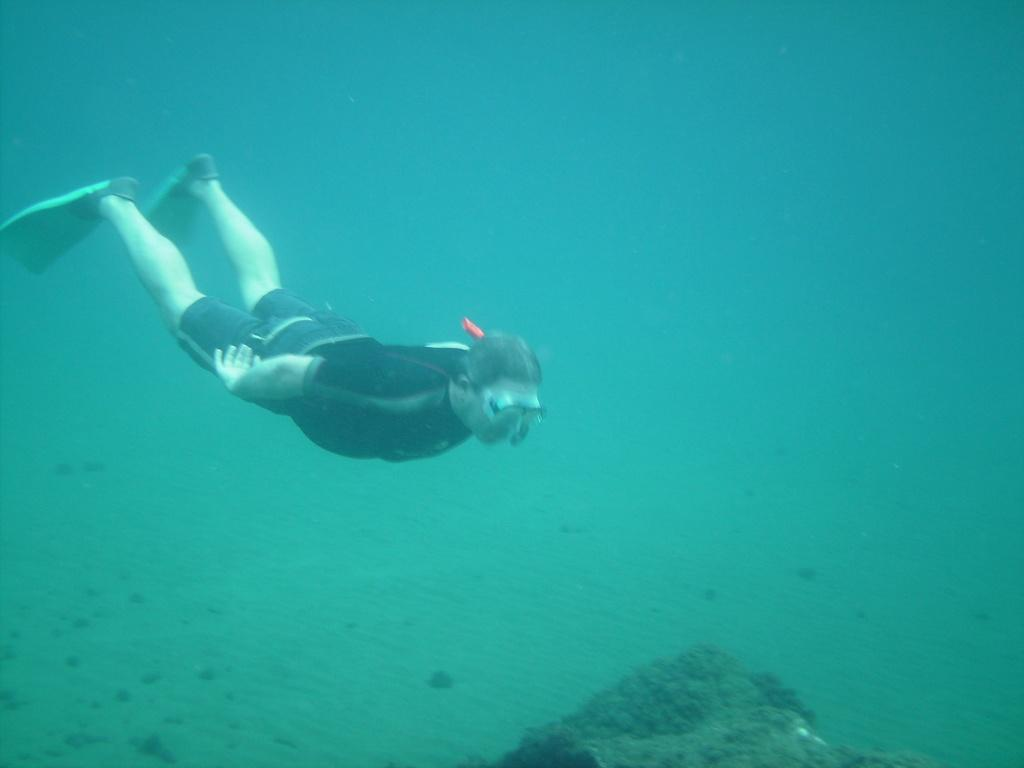What is the main element in the image? There is water in the image. What is the man in the water doing? The man is swimming in the water. What protective gear is the man wearing? The man is wearing goggles. Can you describe the object at the bottom of the image? Unfortunately, the facts provided do not give enough information about the object at the bottom of the image. What color is the background of the image? The background of the image is blue in color. What type of root can be seen growing in the water in the image? There is no root visible in the image; it features a man swimming in the water. How does the man compare his swimming skills to those of a professional swimmer in the image? There is no comparison made in the image; it simply shows a man swimming in the water. 